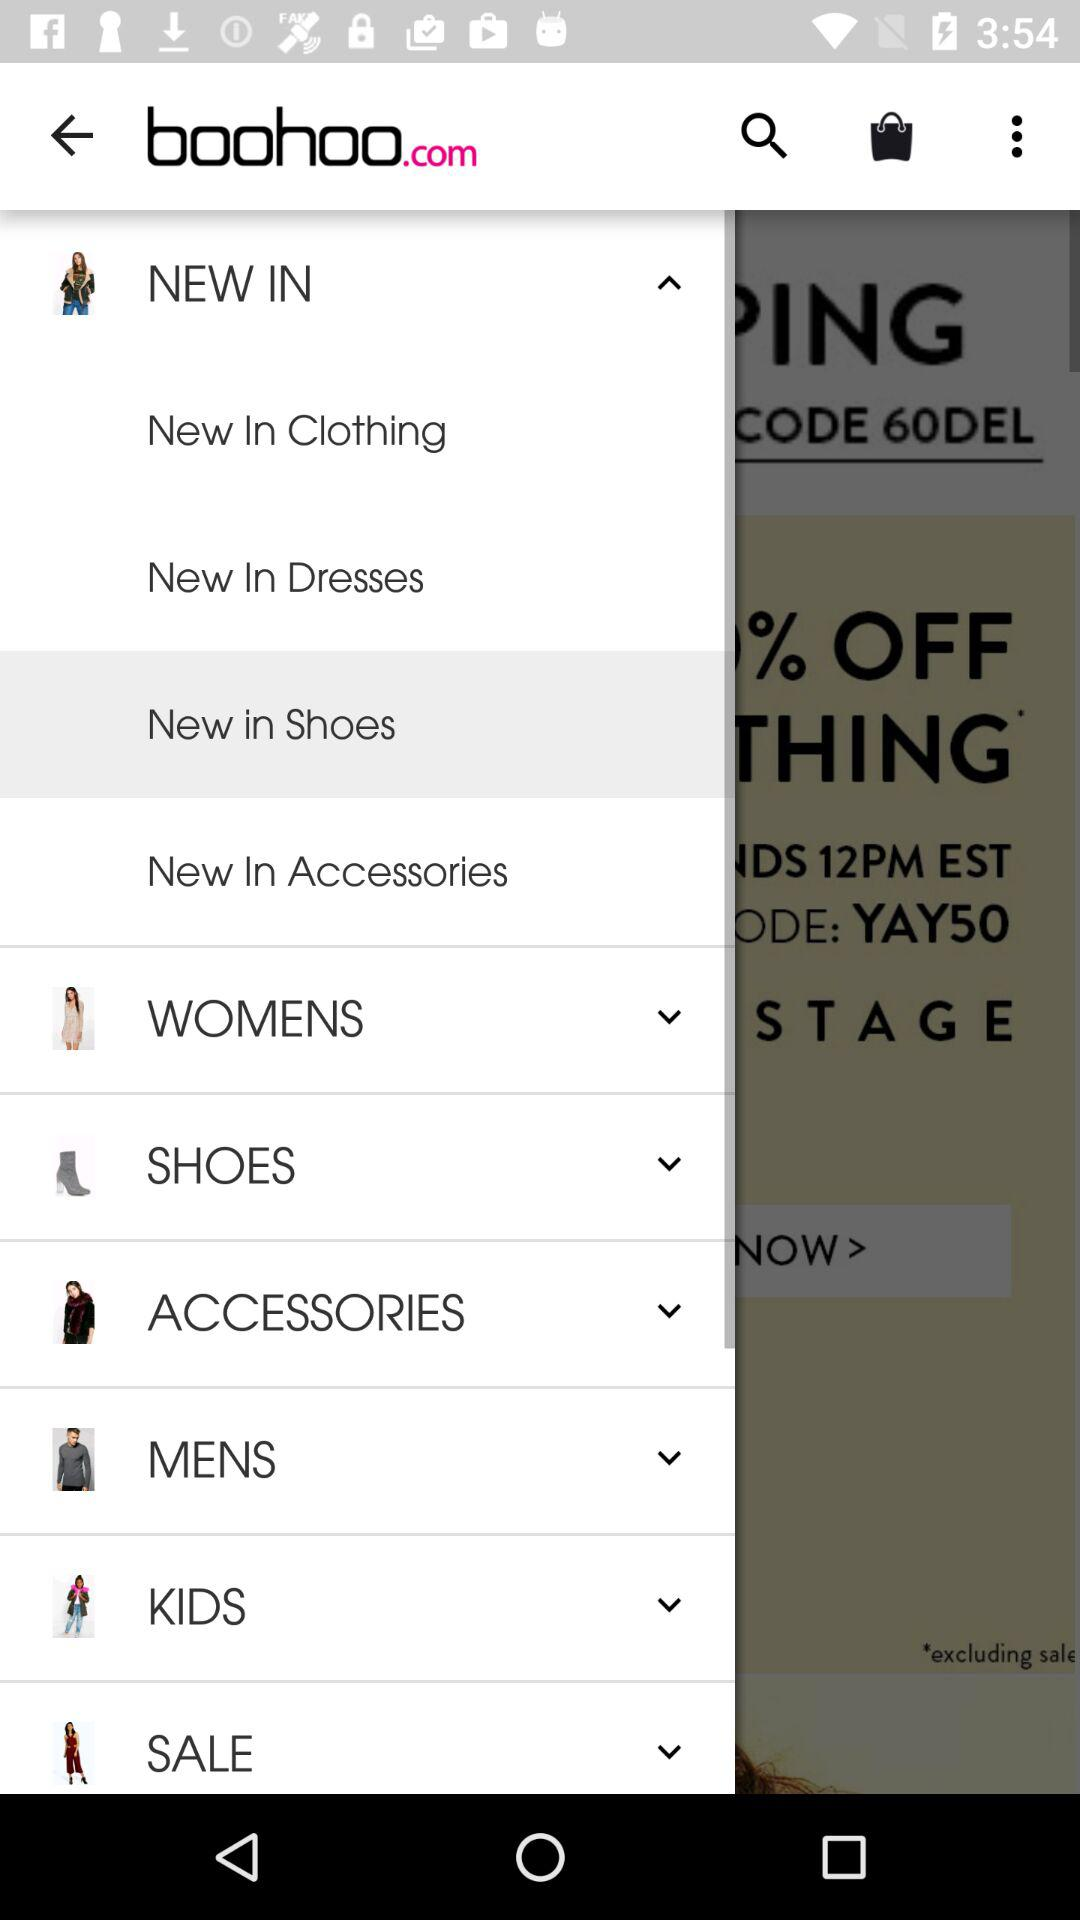How many unread messages are there?
When the provided information is insufficient, respond with <no answer>. <no answer> 